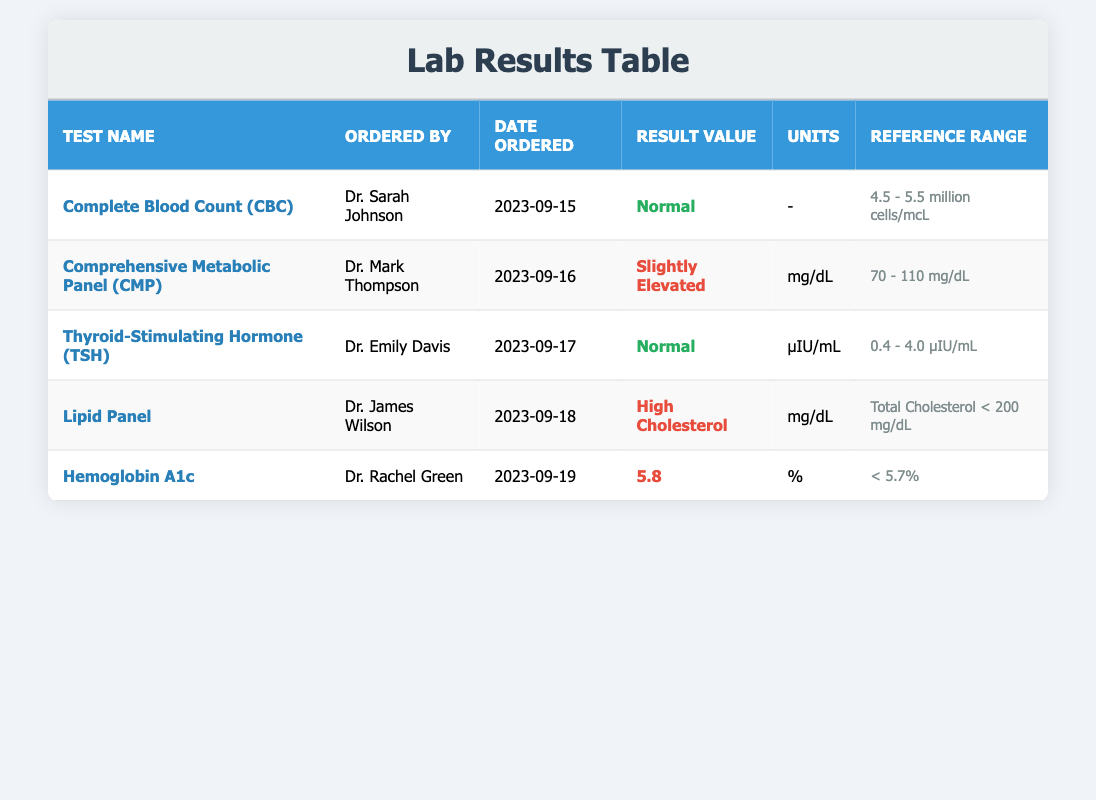What is the result value for the Complete Blood Count (CBC)? The row for the Complete Blood Count (CBC) shows that the result value is "Normal". This can be directly found by looking at the corresponding cell in the "Result Value" column.
Answer: Normal Which test was ordered by Dr. Mark Thompson? Looking at the table, Dr. Mark Thompson ordered the Comprehensive Metabolic Panel (CMP). This is found in the "Ordered By" column and the corresponding "Test Name" column.
Answer: Comprehensive Metabolic Panel (CMP) How many tests were ordered to evaluate cholesterol levels? From the table, there are two tests related to cholesterol: the Lipid Panel and the Hemoglobin A1c (although it is a measure of blood glucose, it may impact cholesterol control). Therefore, the total count of tests specifically associated with cholesterol levels is two.
Answer: 2 Did Dr. Emily Davis order any tests that showed elevated results? According to the table, Dr. Emily Davis ordered the Thyroid-Stimulating Hormone (TSH) test, which has a result value of "Normal", indicating that the test did not show elevated results. Thus, the answer would be no.
Answer: No What is the average result value of tests ordered, considering only those that are numeric? The numeric result values are from the Hemoglobin A1c (5.8) and the slightly elevated Comprehensive Metabolic Panel (CMP) (which doesn't provide a numeric value but has a reference of 70-110 mg/dL). Since only one numeric valid result is present, 5.8 itself can be taken as the average because it is the only direct numeric result. The calculation can be summarized as 5.8 / 1 = 5.8.
Answer: 5.8 What is the reference range for the Hemoglobin A1c test? The table provides the reference range for the Hemoglobin A1c test as "< 5.7%". This information is directly located in the reference range column corresponding to the Hemoglobin A1c row.
Answer: < 5.7% Which physician ordered the test with high cholesterol result? The table shows that Dr. James Wilson ordered the Lipid Panel test, which had a result of "High Cholesterol". This can be deduced by checking the "Ordered By" column and matching it with the corresponding result.
Answer: Dr. James Wilson How many tests had normal results, and how many had abnormal results? By reviewing the table, there are 3 tests marked as normal (Complete Blood Count, TSH) and 3 results marked as abnormal (Slightly Elevated CMP, High Cholesterol from Lipid Panel, and Hemoglobin A1c). To get the comprehensive view, we can summarize: Normal (3) and Abnormal (3).
Answer: 3 normal, 3 abnormal 